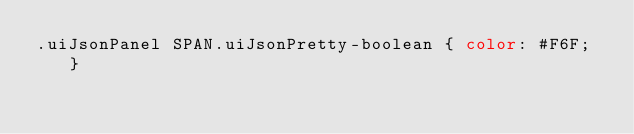<code> <loc_0><loc_0><loc_500><loc_500><_CSS_>.uiJsonPanel SPAN.uiJsonPretty-boolean { color: #F6F; }
</code> 